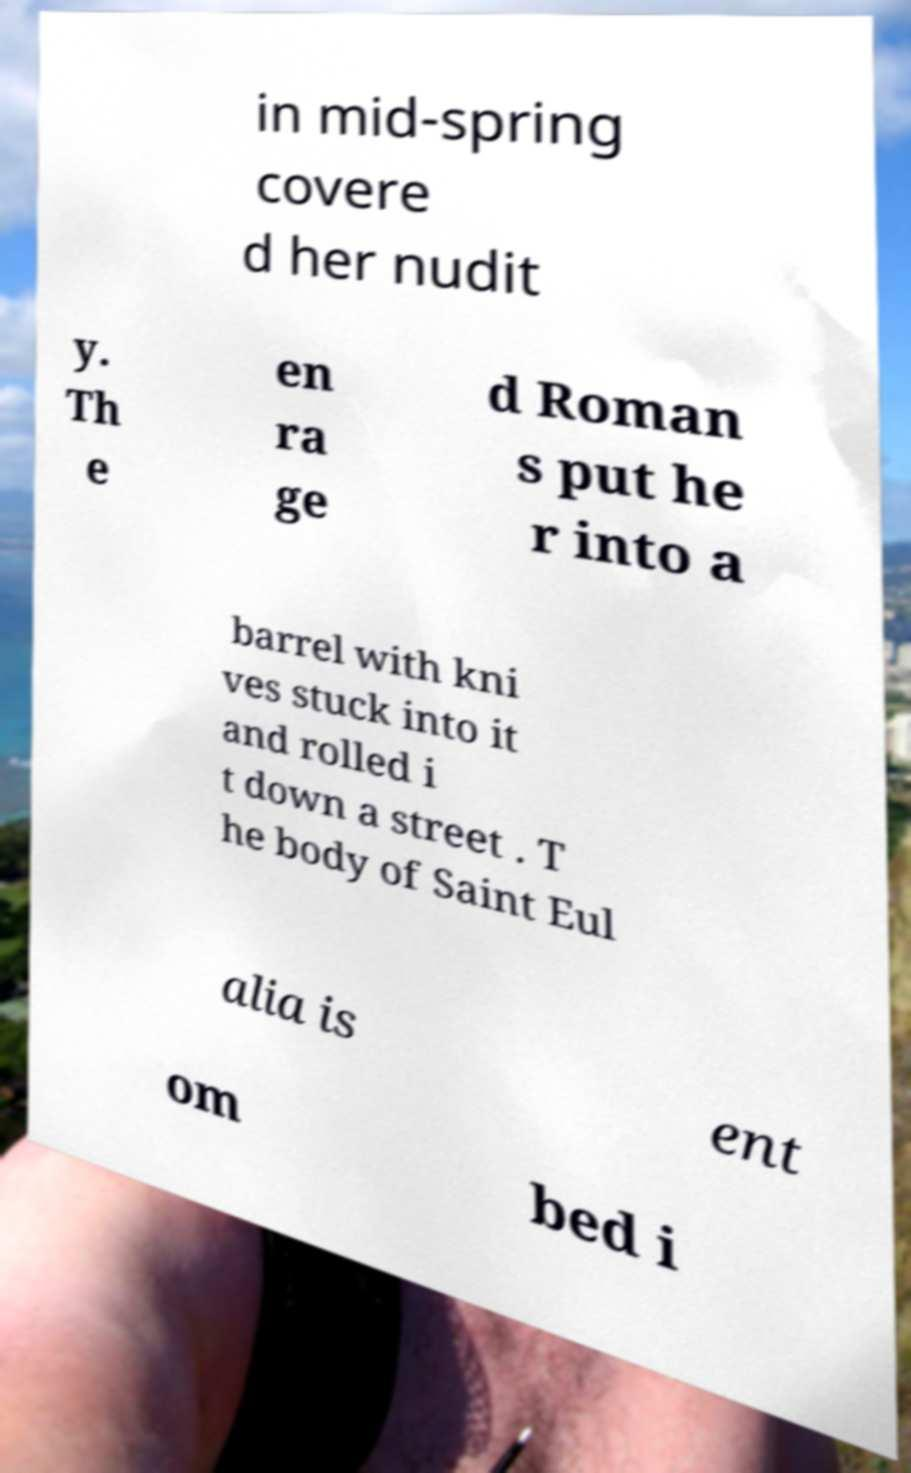I need the written content from this picture converted into text. Can you do that? in mid-spring covere d her nudit y. Th e en ra ge d Roman s put he r into a barrel with kni ves stuck into it and rolled i t down a street . T he body of Saint Eul alia is ent om bed i 